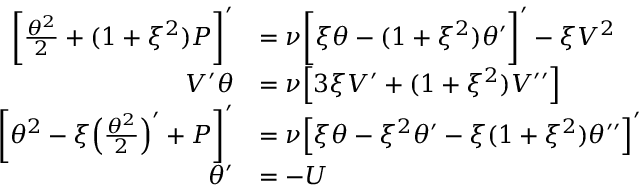<formula> <loc_0><loc_0><loc_500><loc_500>\begin{array} { r l } { \left [ \frac { \theta ^ { 2 } } { 2 } + ( 1 + \xi ^ { 2 } ) P \right ] ^ { \prime } } & { = \nu \left [ \xi \theta - ( 1 + \xi ^ { 2 } ) \theta ^ { \prime } \right ] ^ { \prime } - \xi V ^ { 2 } } \\ { V ^ { \prime } \theta } & { = \nu \left [ 3 \xi V ^ { \prime } + ( 1 + \xi ^ { 2 } ) V ^ { \prime \prime } \right ] } \\ { \left [ \theta ^ { 2 } - \xi \left ( \frac { \theta ^ { 2 } } { 2 } \right ) ^ { \prime } + P \right ] ^ { \prime } } & { = \nu \left [ \xi \theta - \xi ^ { 2 } \theta ^ { \prime } - \xi ( 1 + \xi ^ { 2 } ) \theta ^ { \prime \prime } \right ] ^ { \prime } } \\ { \theta ^ { \prime } } & { = - U } \end{array}</formula> 